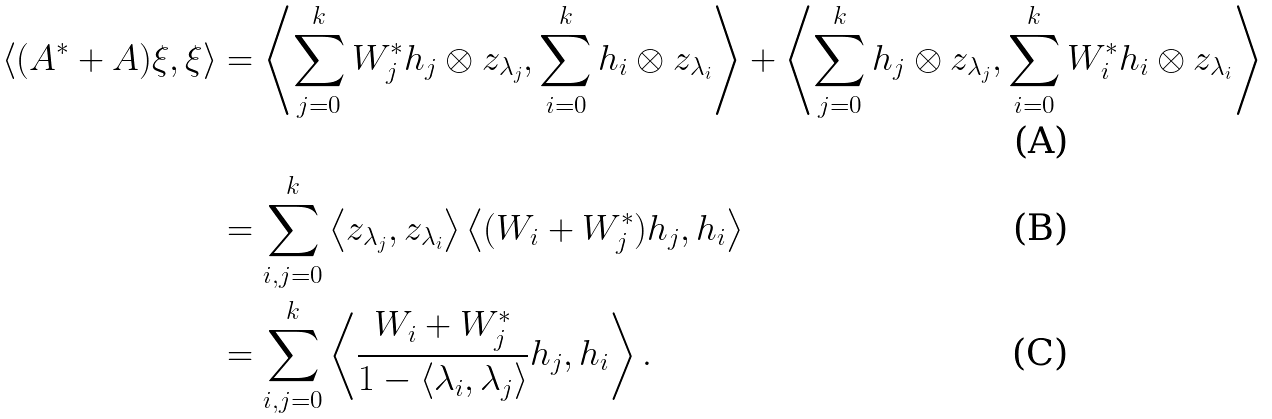Convert formula to latex. <formula><loc_0><loc_0><loc_500><loc_500>\left < ( A ^ { * } + A ) \xi , \xi \right > & = \left < \sum _ { j = 0 } ^ { k } W _ { j } ^ { * } h _ { j } \otimes z _ { \lambda _ { j } } , \sum _ { i = 0 } ^ { k } h _ { i } \otimes z _ { \lambda _ { i } } \right > + \left < \sum _ { j = 0 } ^ { k } h _ { j } \otimes z _ { \lambda _ { j } } , \sum _ { i = 0 } ^ { k } W _ { i } ^ { * } h _ { i } \otimes z _ { \lambda _ { i } } \right > \\ & = \sum _ { i , j = 0 } ^ { k } \left < z _ { \lambda _ { j } } , z _ { \lambda _ { i } } \right > \left < ( W _ { i } + W _ { j } ^ { * } ) h _ { j } , h _ { i } \right > \\ & = \sum _ { i , j = 0 } ^ { k } \left < \frac { W _ { i } + W _ { j } ^ { * } } { 1 - \left < \lambda _ { i } , \lambda _ { j } \right > } h _ { j } , h _ { i } \right > .</formula> 